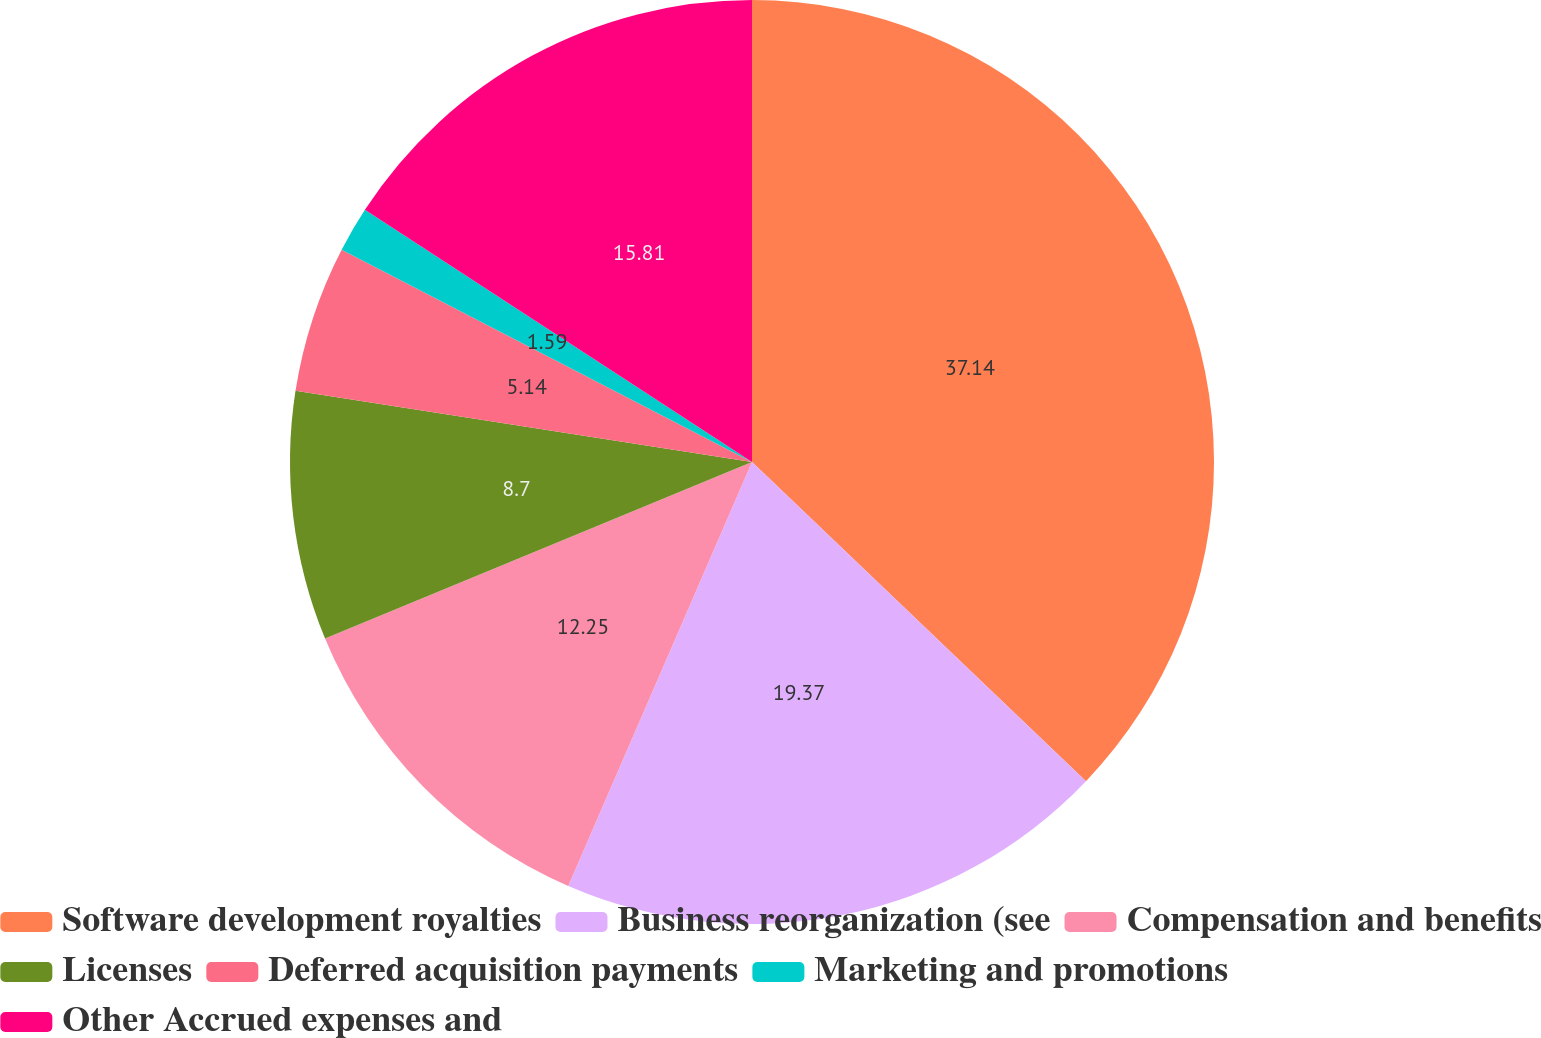Convert chart. <chart><loc_0><loc_0><loc_500><loc_500><pie_chart><fcel>Software development royalties<fcel>Business reorganization (see<fcel>Compensation and benefits<fcel>Licenses<fcel>Deferred acquisition payments<fcel>Marketing and promotions<fcel>Other Accrued expenses and<nl><fcel>37.14%<fcel>19.37%<fcel>12.25%<fcel>8.7%<fcel>5.14%<fcel>1.59%<fcel>15.81%<nl></chart> 